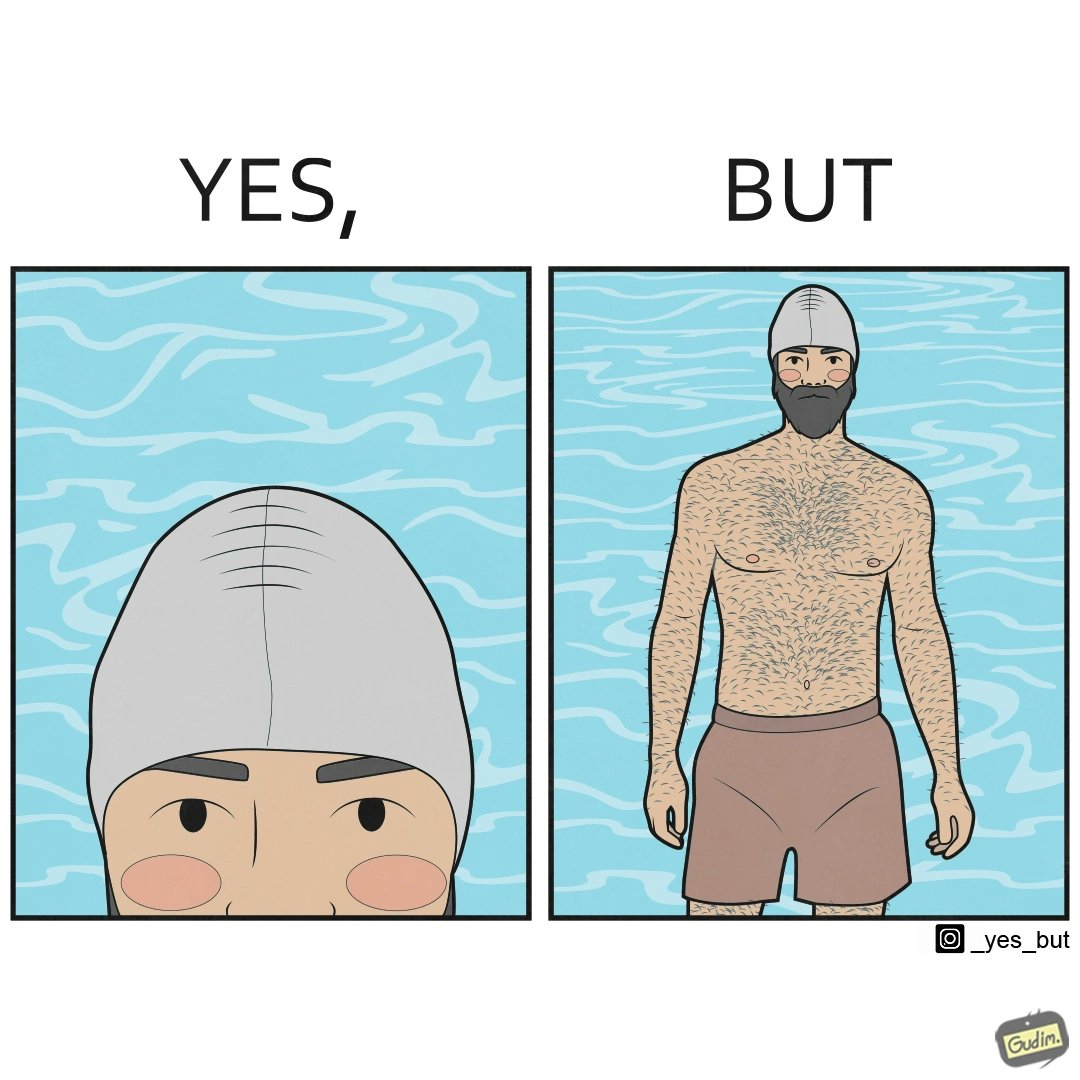Describe the contrast between the left and right parts of this image. In the left part of the image: a person's face is shown wearing some cap, probably swimming cap In the right part of the image: a person in shorts wearing a swimming cap standing near some water body, having beard and hairs all over his body 